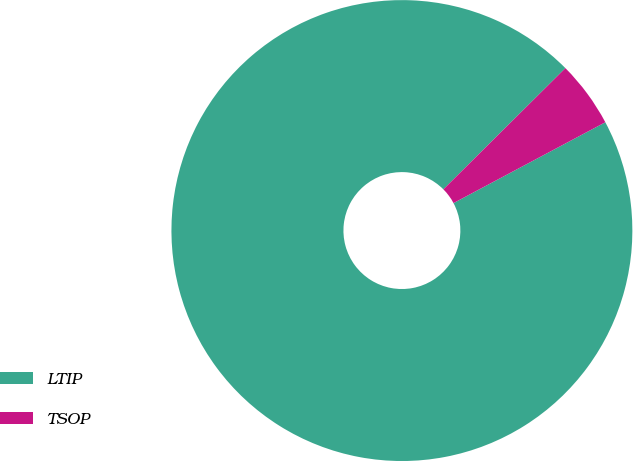<chart> <loc_0><loc_0><loc_500><loc_500><pie_chart><fcel>LTIP<fcel>TSOP<nl><fcel>95.34%<fcel>4.66%<nl></chart> 